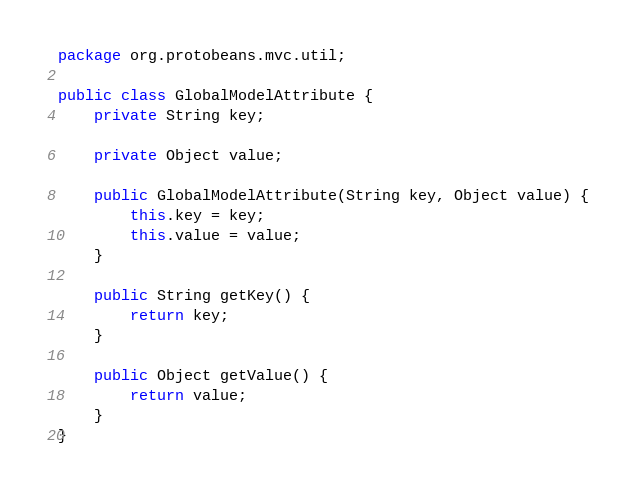Convert code to text. <code><loc_0><loc_0><loc_500><loc_500><_Java_>package org.protobeans.mvc.util;

public class GlobalModelAttribute {
    private String key;
    
    private Object value;

    public GlobalModelAttribute(String key, Object value) {
        this.key = key;
        this.value = value;
    }

    public String getKey() {
        return key;
    }

    public Object getValue() {
        return value;
    }
}
</code> 